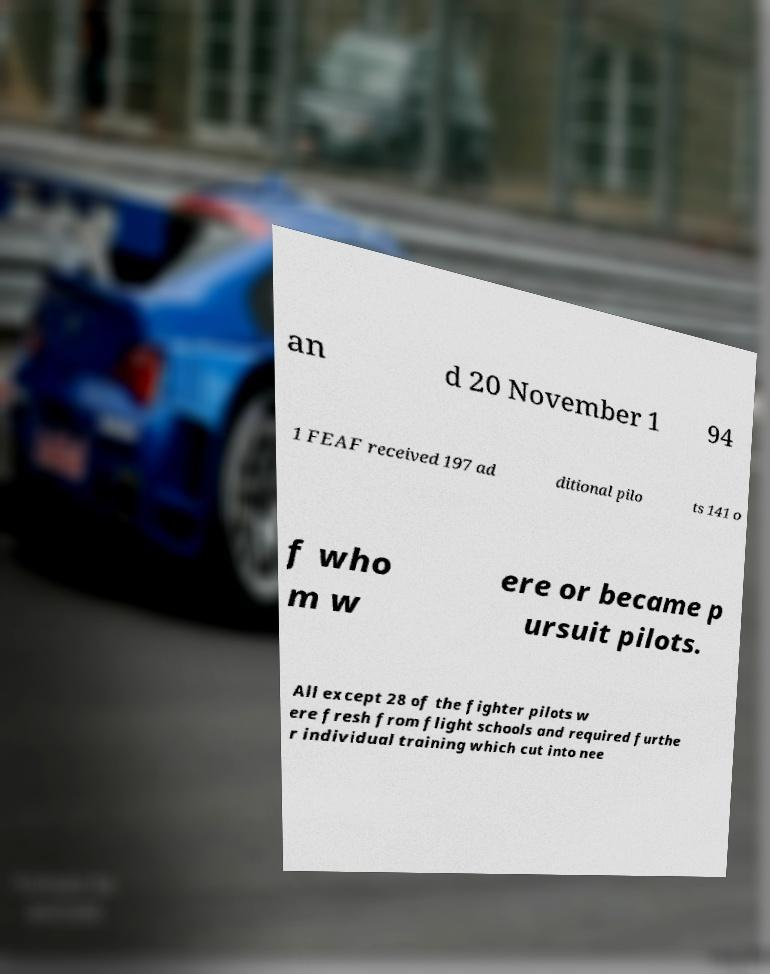Could you extract and type out the text from this image? an d 20 November 1 94 1 FEAF received 197 ad ditional pilo ts 141 o f who m w ere or became p ursuit pilots. All except 28 of the fighter pilots w ere fresh from flight schools and required furthe r individual training which cut into nee 